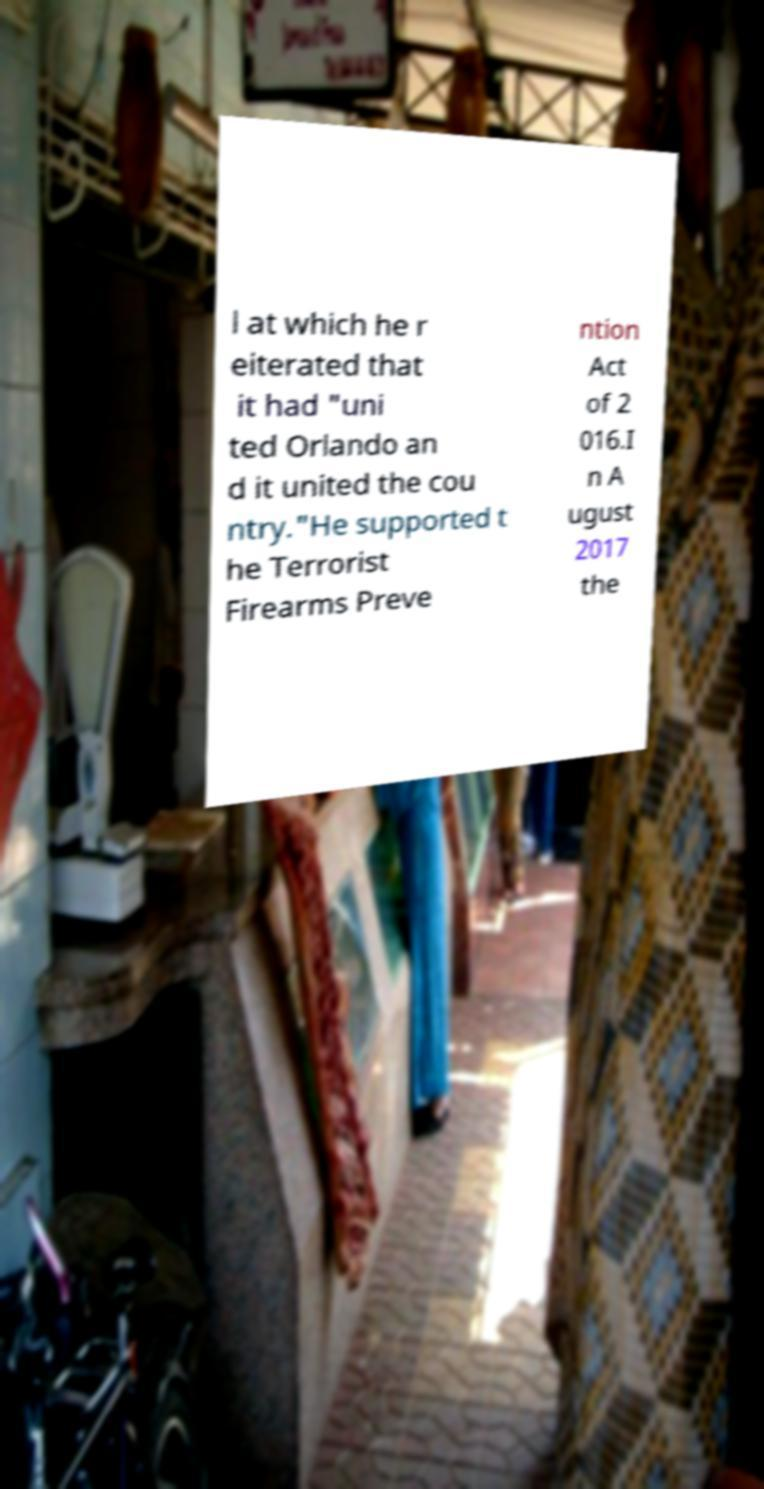Please identify and transcribe the text found in this image. l at which he r eiterated that it had "uni ted Orlando an d it united the cou ntry."He supported t he Terrorist Firearms Preve ntion Act of 2 016.I n A ugust 2017 the 